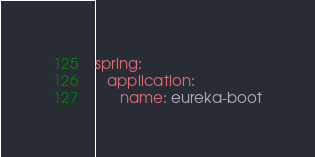Convert code to text. <code><loc_0><loc_0><loc_500><loc_500><_YAML_>spring:
   application:
      name: eureka-boot</code> 